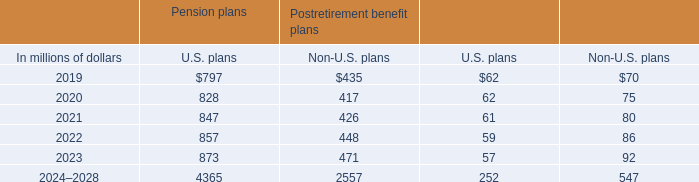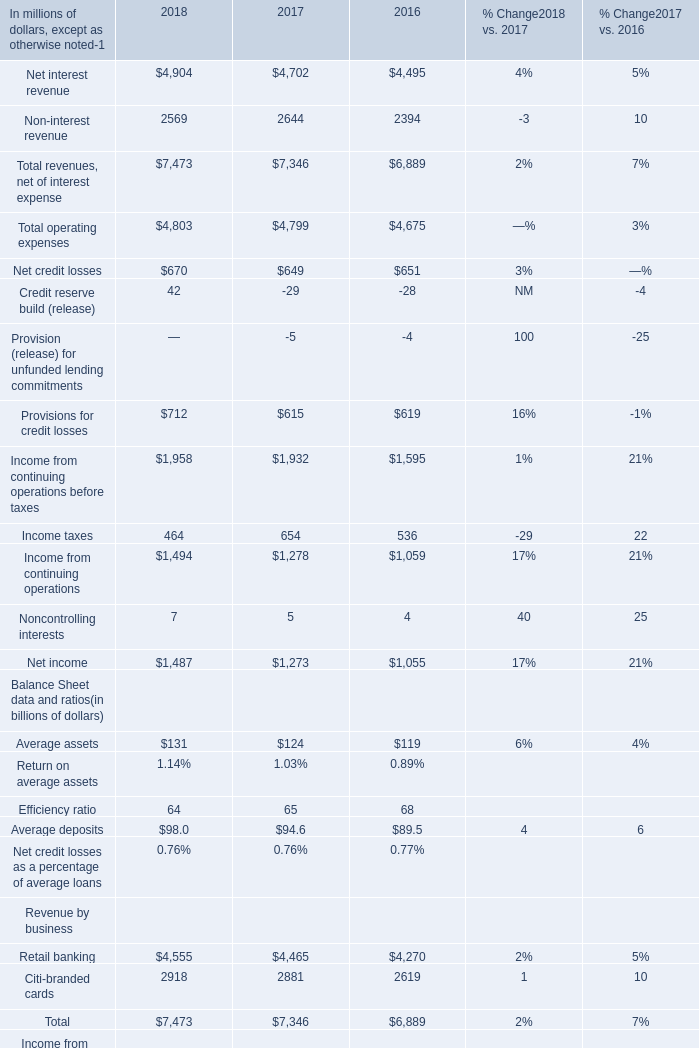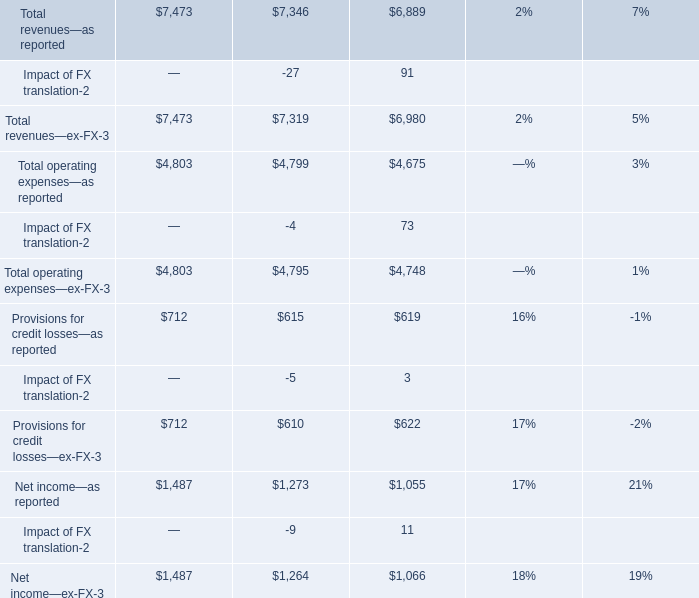What is the growing rate of Income from continuing operations before taxes in the year with the most Provisions for credit losses? 
Computations: ((1958 - 1932) / 1958)
Answer: 0.01328. 